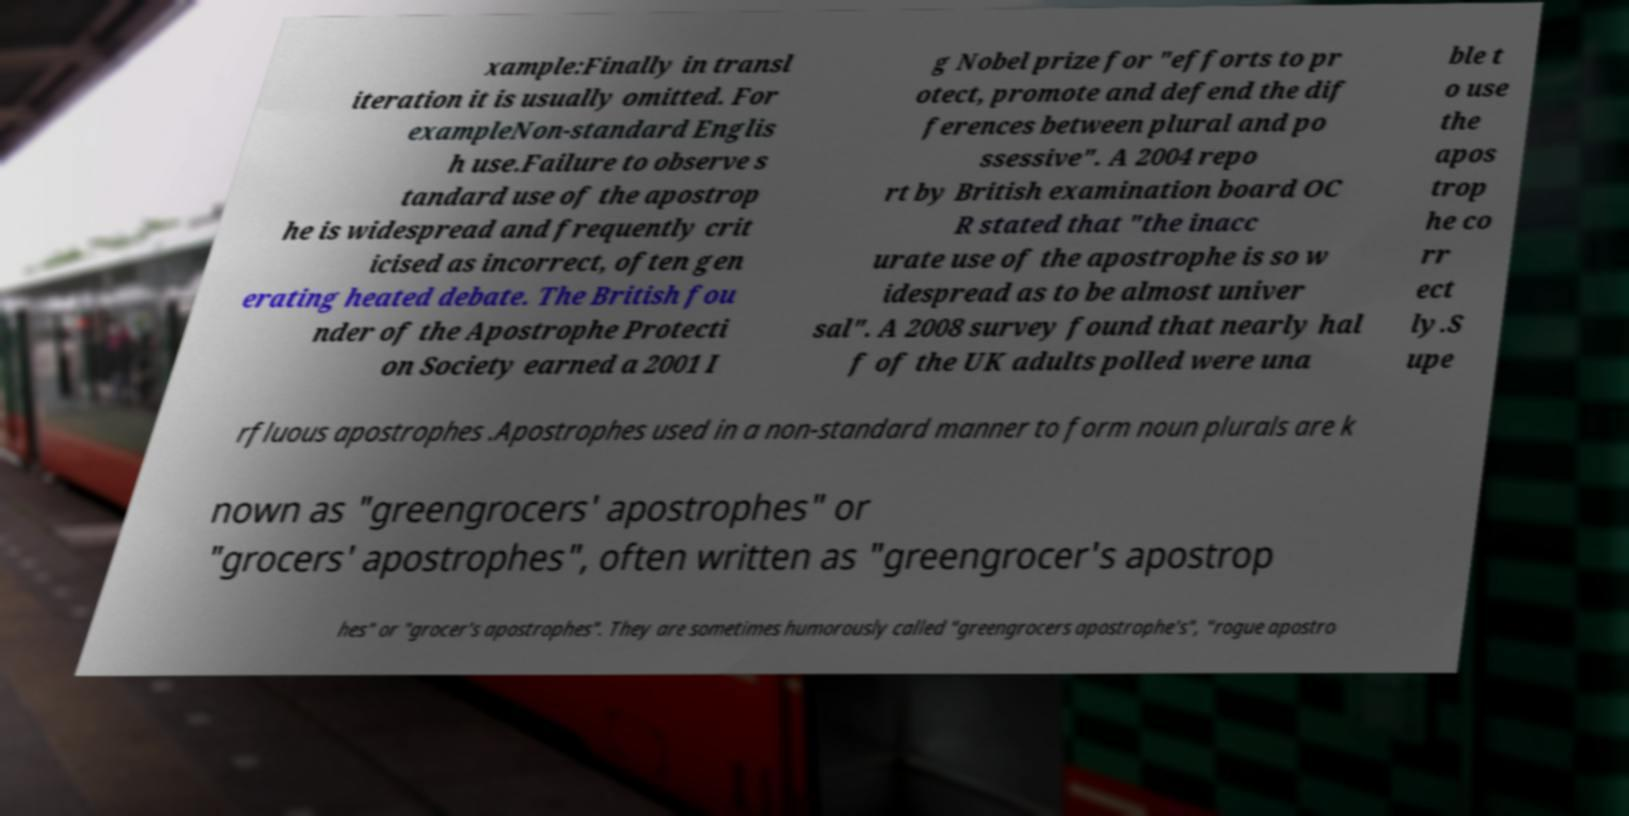For documentation purposes, I need the text within this image transcribed. Could you provide that? xample:Finally in transl iteration it is usually omitted. For exampleNon-standard Englis h use.Failure to observe s tandard use of the apostrop he is widespread and frequently crit icised as incorrect, often gen erating heated debate. The British fou nder of the Apostrophe Protecti on Society earned a 2001 I g Nobel prize for "efforts to pr otect, promote and defend the dif ferences between plural and po ssessive". A 2004 repo rt by British examination board OC R stated that "the inacc urate use of the apostrophe is so w idespread as to be almost univer sal". A 2008 survey found that nearly hal f of the UK adults polled were una ble t o use the apos trop he co rr ect ly.S upe rfluous apostrophes .Apostrophes used in a non-standard manner to form noun plurals are k nown as "greengrocers' apostrophes" or "grocers' apostrophes", often written as "greengrocer's apostrop hes" or "grocer's apostrophes". They are sometimes humorously called "greengrocers apostrophe's", "rogue apostro 